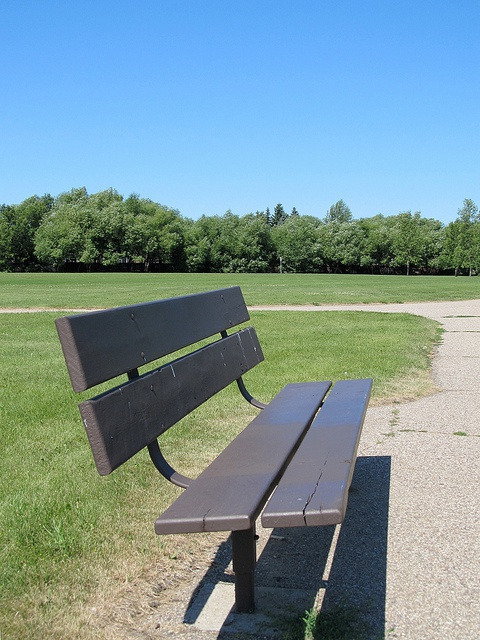Describe the objects in this image and their specific colors. I can see a bench in lightblue, black, and gray tones in this image. 